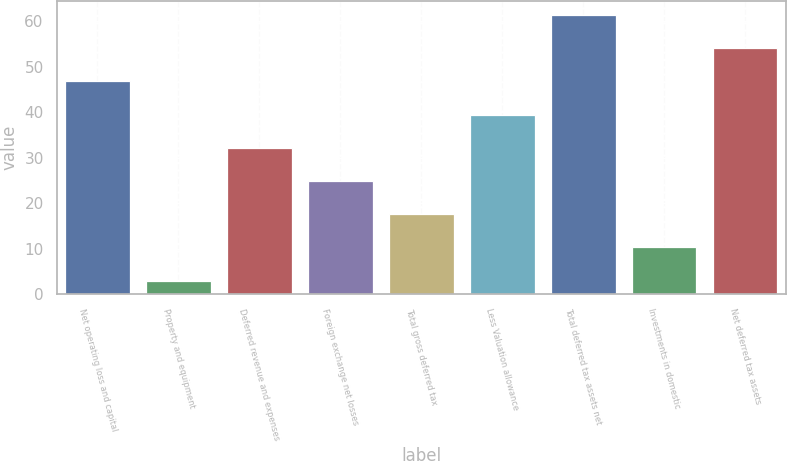Convert chart. <chart><loc_0><loc_0><loc_500><loc_500><bar_chart><fcel>Net operating loss and capital<fcel>Property and equipment<fcel>Deferred revenue and expenses<fcel>Foreign exchange net losses<fcel>Total gross deferred tax<fcel>Less Valuation allowance<fcel>Total deferred tax assets net<fcel>Investments in domestic<fcel>Net deferred tax assets<nl><fcel>46.8<fcel>3<fcel>32.2<fcel>24.9<fcel>17.6<fcel>39.5<fcel>61.4<fcel>10.3<fcel>54.1<nl></chart> 